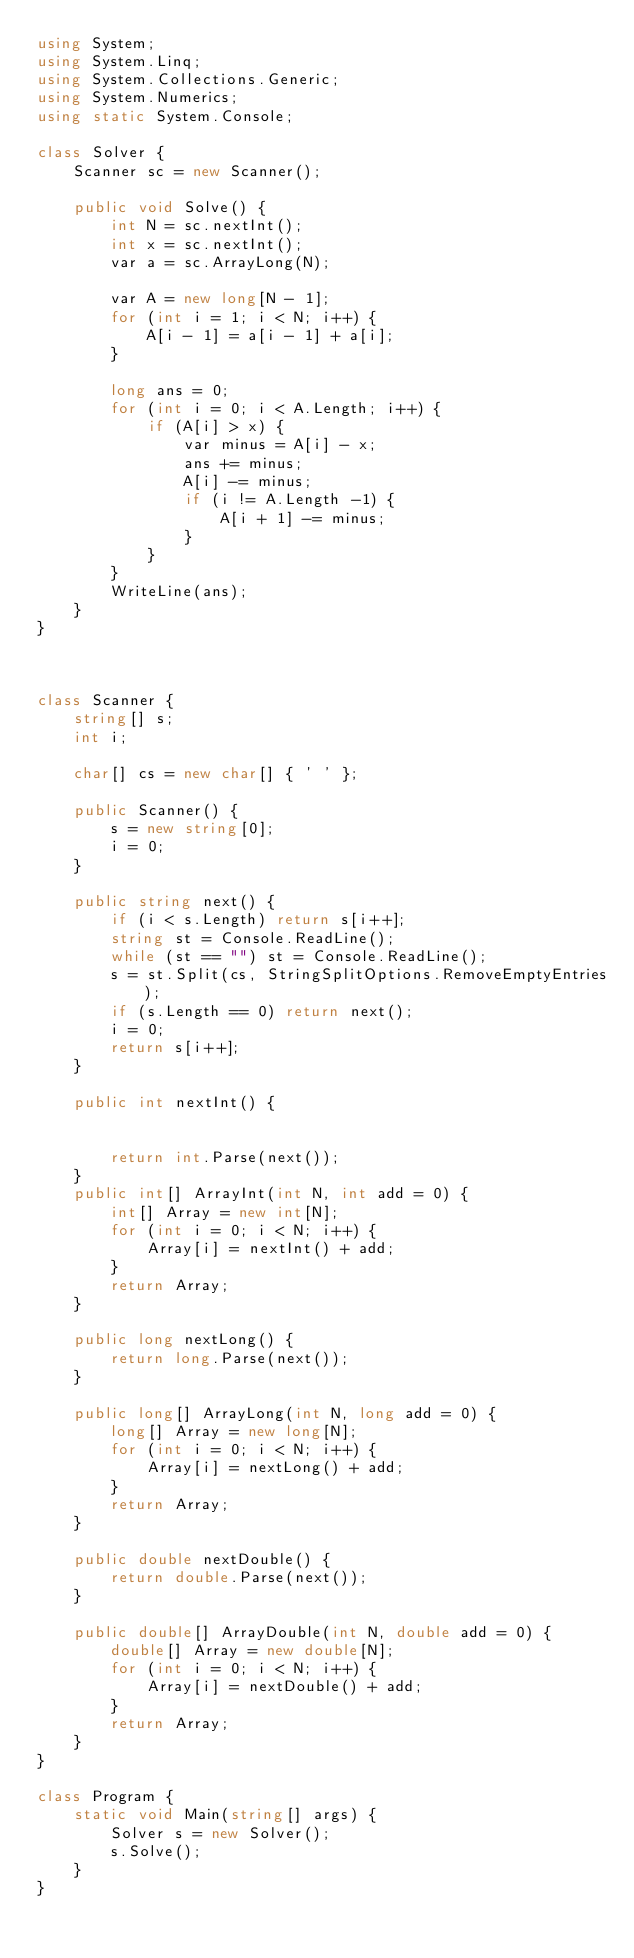Convert code to text. <code><loc_0><loc_0><loc_500><loc_500><_C#_>using System;
using System.Linq;
using System.Collections.Generic;
using System.Numerics;
using static System.Console;

class Solver {
    Scanner sc = new Scanner();

    public void Solve() {
        int N = sc.nextInt();
        int x = sc.nextInt();
        var a = sc.ArrayLong(N);

        var A = new long[N - 1];
        for (int i = 1; i < N; i++) {
            A[i - 1] = a[i - 1] + a[i];
        }

        long ans = 0;
        for (int i = 0; i < A.Length; i++) {
            if (A[i] > x) {
                var minus = A[i] - x;
                ans += minus;
                A[i] -= minus;
                if (i != A.Length -1) {
                    A[i + 1] -= minus;
                }
            }
        }
        WriteLine(ans);
    }
}



class Scanner {
    string[] s;
    int i;

    char[] cs = new char[] { ' ' };

    public Scanner() {
        s = new string[0];
        i = 0;
    }

    public string next() {
        if (i < s.Length) return s[i++];
        string st = Console.ReadLine();
        while (st == "") st = Console.ReadLine();
        s = st.Split(cs, StringSplitOptions.RemoveEmptyEntries);
        if (s.Length == 0) return next();
        i = 0;
        return s[i++];
    }

    public int nextInt() {


        return int.Parse(next());
    }
    public int[] ArrayInt(int N, int add = 0) {
        int[] Array = new int[N];
        for (int i = 0; i < N; i++) {
            Array[i] = nextInt() + add;
        }
        return Array;
    }

    public long nextLong() {
        return long.Parse(next());
    }

    public long[] ArrayLong(int N, long add = 0) {
        long[] Array = new long[N];
        for (int i = 0; i < N; i++) {
            Array[i] = nextLong() + add;
        }
        return Array;
    }

    public double nextDouble() {
        return double.Parse(next());
    }

    public double[] ArrayDouble(int N, double add = 0) {
        double[] Array = new double[N];
        for (int i = 0; i < N; i++) {
            Array[i] = nextDouble() + add;
        }
        return Array;
    }
}

class Program {
    static void Main(string[] args) {
        Solver s = new Solver();
        s.Solve();
    }
}</code> 